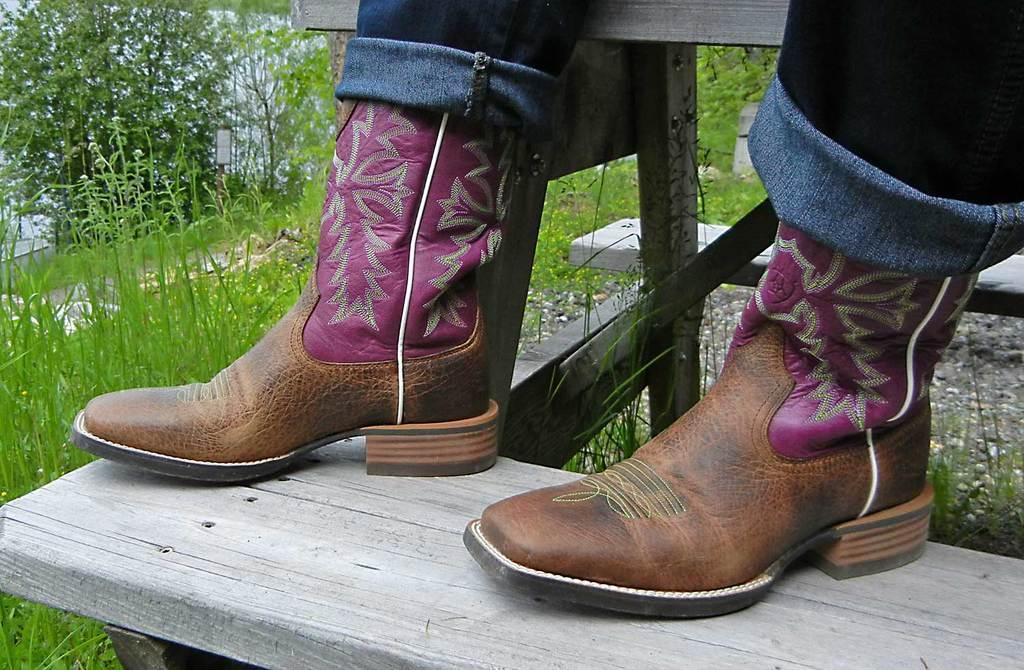Please provide a concise description of this image. In this image in the center there is one person's legs are visible, and he is on a wooden stairs. In the background there are some plants and grass. 